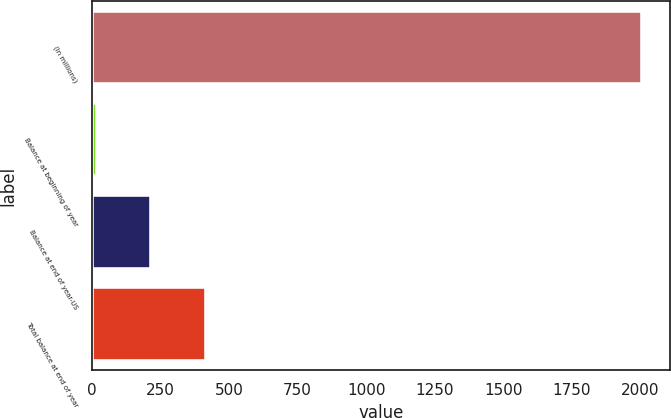Convert chart to OTSL. <chart><loc_0><loc_0><loc_500><loc_500><bar_chart><fcel>(In millions)<fcel>Balance at beginning of year<fcel>Balance at end of year-US<fcel>Total balance at end of year<nl><fcel>2007<fcel>18<fcel>216.9<fcel>415.8<nl></chart> 